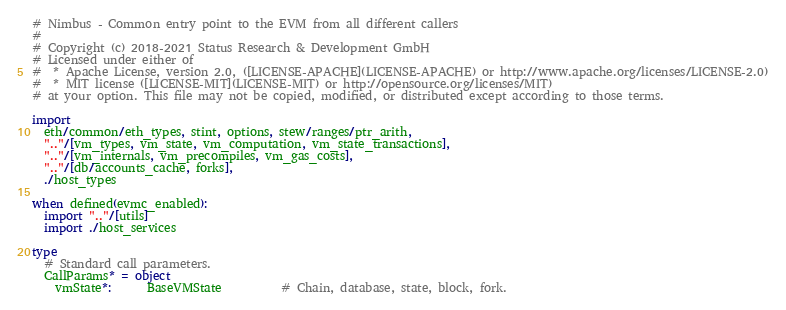Convert code to text. <code><loc_0><loc_0><loc_500><loc_500><_Nim_># Nimbus - Common entry point to the EVM from all different callers
#
# Copyright (c) 2018-2021 Status Research & Development GmbH
# Licensed under either of
#  * Apache License, version 2.0, ([LICENSE-APACHE](LICENSE-APACHE) or http://www.apache.org/licenses/LICENSE-2.0)
#  * MIT license ([LICENSE-MIT](LICENSE-MIT) or http://opensource.org/licenses/MIT)
# at your option. This file may not be copied, modified, or distributed except according to those terms.

import
  eth/common/eth_types, stint, options, stew/ranges/ptr_arith,
  ".."/[vm_types, vm_state, vm_computation, vm_state_transactions],
  ".."/[vm_internals, vm_precompiles, vm_gas_costs],
  ".."/[db/accounts_cache, forks],
  ./host_types

when defined(evmc_enabled):
  import ".."/[utils]
  import ./host_services

type
  # Standard call parameters.
  CallParams* = object
    vmState*:      BaseVMState          # Chain, database, state, block, fork.</code> 